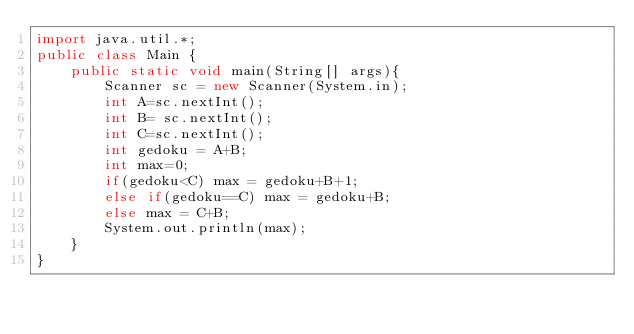Convert code to text. <code><loc_0><loc_0><loc_500><loc_500><_Java_>import java.util.*;
public class Main {
    public static void main(String[] args){
        Scanner sc = new Scanner(System.in);
        int A=sc.nextInt();
        int B= sc.nextInt();
        int C=sc.nextInt();
        int gedoku = A+B;
        int max=0;
        if(gedoku<C) max = gedoku+B+1;
        else if(gedoku==C) max = gedoku+B;
        else max = C+B;
        System.out.println(max);
    }
}</code> 